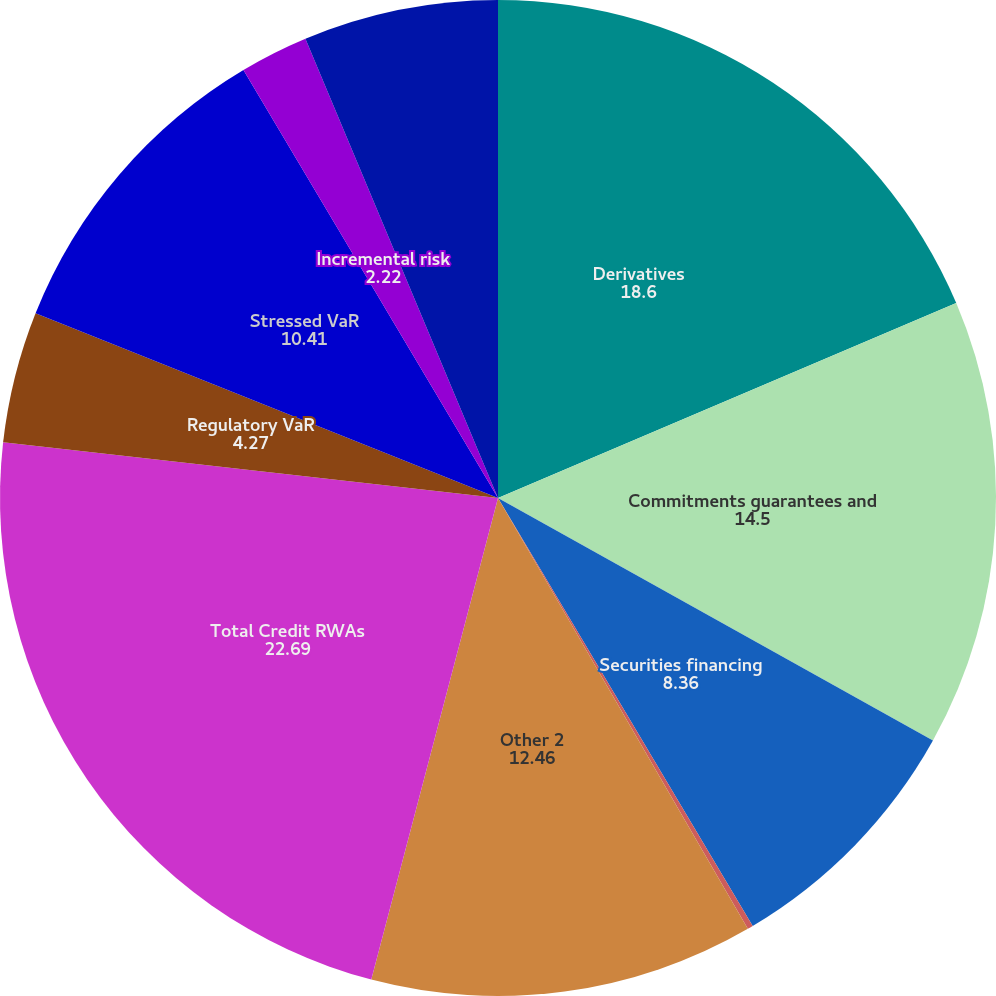Convert chart to OTSL. <chart><loc_0><loc_0><loc_500><loc_500><pie_chart><fcel>Derivatives<fcel>Commitments guarantees and<fcel>Securities financing<fcel>Equity investments<fcel>Other 2<fcel>Total Credit RWAs<fcel>Regulatory VaR<fcel>Stressed VaR<fcel>Incremental risk<fcel>Comprehensive risk<nl><fcel>18.6%<fcel>14.5%<fcel>8.36%<fcel>0.18%<fcel>12.46%<fcel>22.69%<fcel>4.27%<fcel>10.41%<fcel>2.22%<fcel>6.32%<nl></chart> 